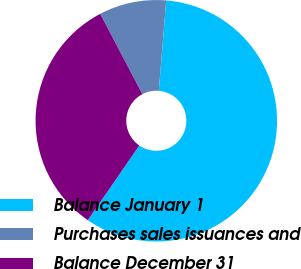<chart> <loc_0><loc_0><loc_500><loc_500><pie_chart><fcel>Balance January 1<fcel>Purchases sales issuances and<fcel>Balance December 31<nl><fcel>58.29%<fcel>9.0%<fcel>32.7%<nl></chart> 